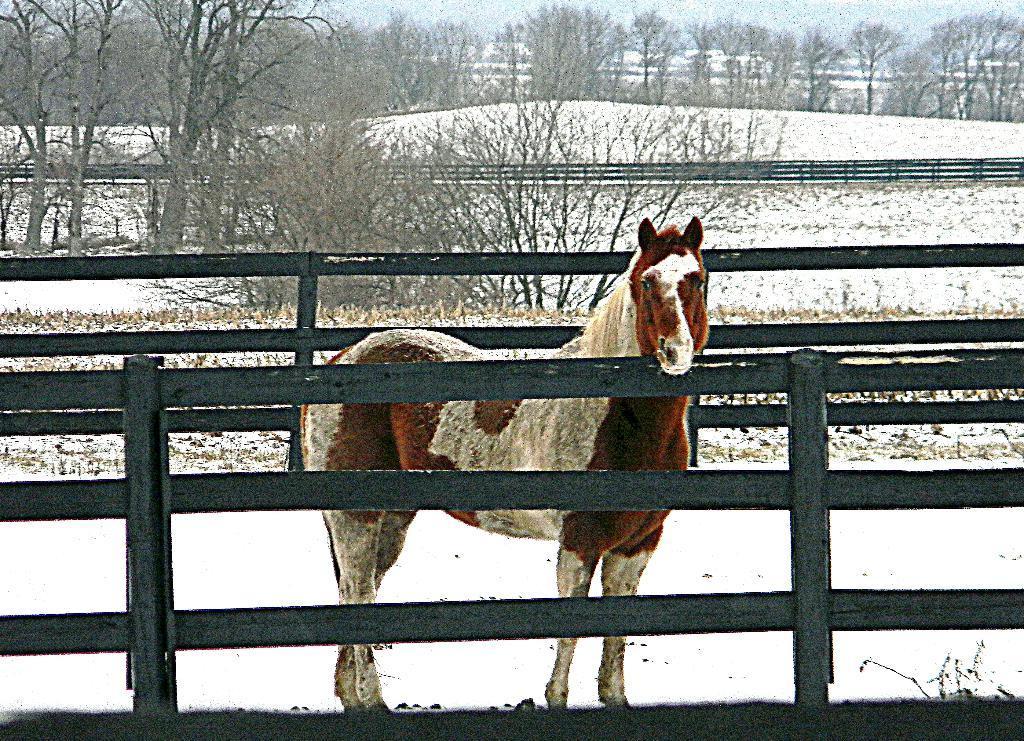Describe this image in one or two sentences. In this image there is a fencing, in the middle there is a horse and the land is covered with snow, in the background there are trees. 